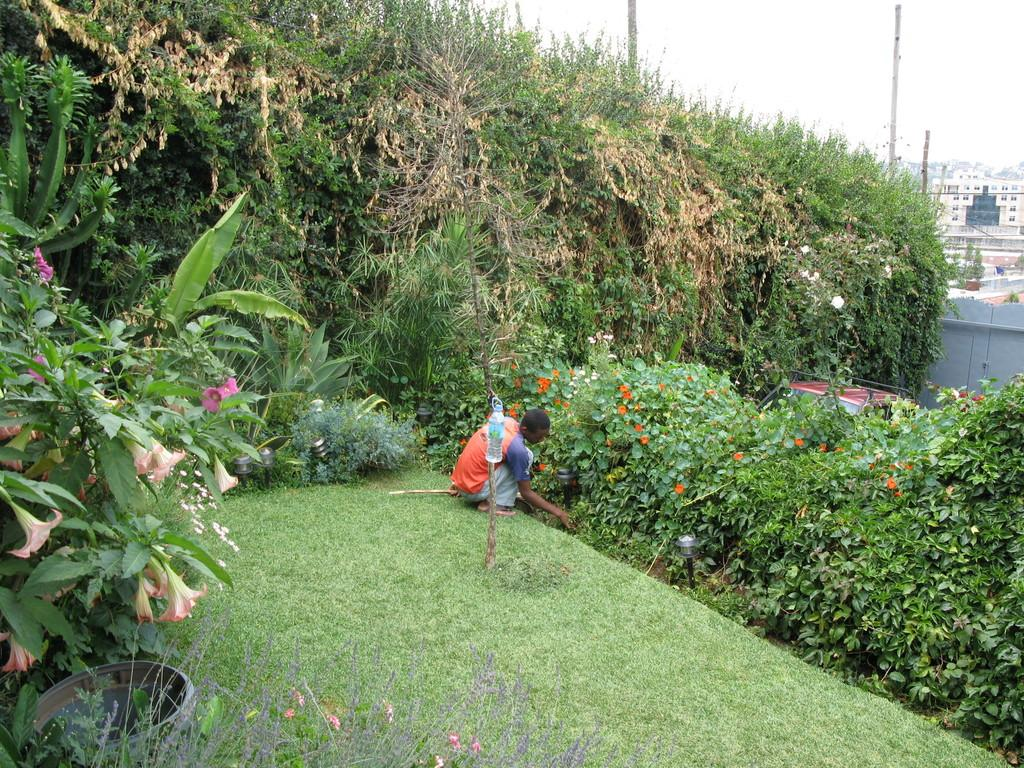What is the person in the image doing? There is a person on the ground in the image, but their activity is not specified. What object can be seen near the person? There is a bottle visible in the image. What type of vegetation is present in the image? There are plants with flowers and trees in the image. What can be seen in the distance in the image? There are buildings in the background of the image, and the sky is visible in the background as well. What type of paste is being used to stick the flag on the person's forehead in the image? There is no flag or paste present in the image; it only features a person on the ground, a bottle, plants with flowers, trees, buildings, and the sky. 